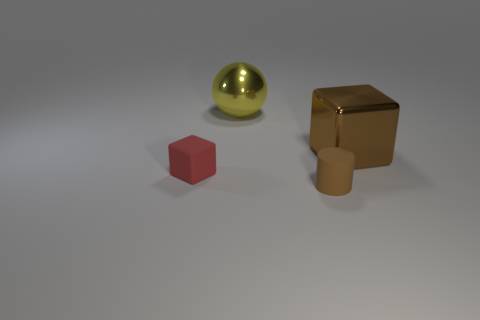Add 2 yellow metal cubes. How many objects exist? 6 Subtract all red cubes. How many cubes are left? 1 Subtract all cylinders. How many objects are left? 3 Subtract 2 cubes. How many cubes are left? 0 Subtract all gray cylinders. Subtract all gray balls. How many cylinders are left? 1 Subtract all large yellow shiny things. Subtract all small brown rubber things. How many objects are left? 2 Add 4 cylinders. How many cylinders are left? 5 Add 1 rubber cylinders. How many rubber cylinders exist? 2 Subtract 0 green cylinders. How many objects are left? 4 